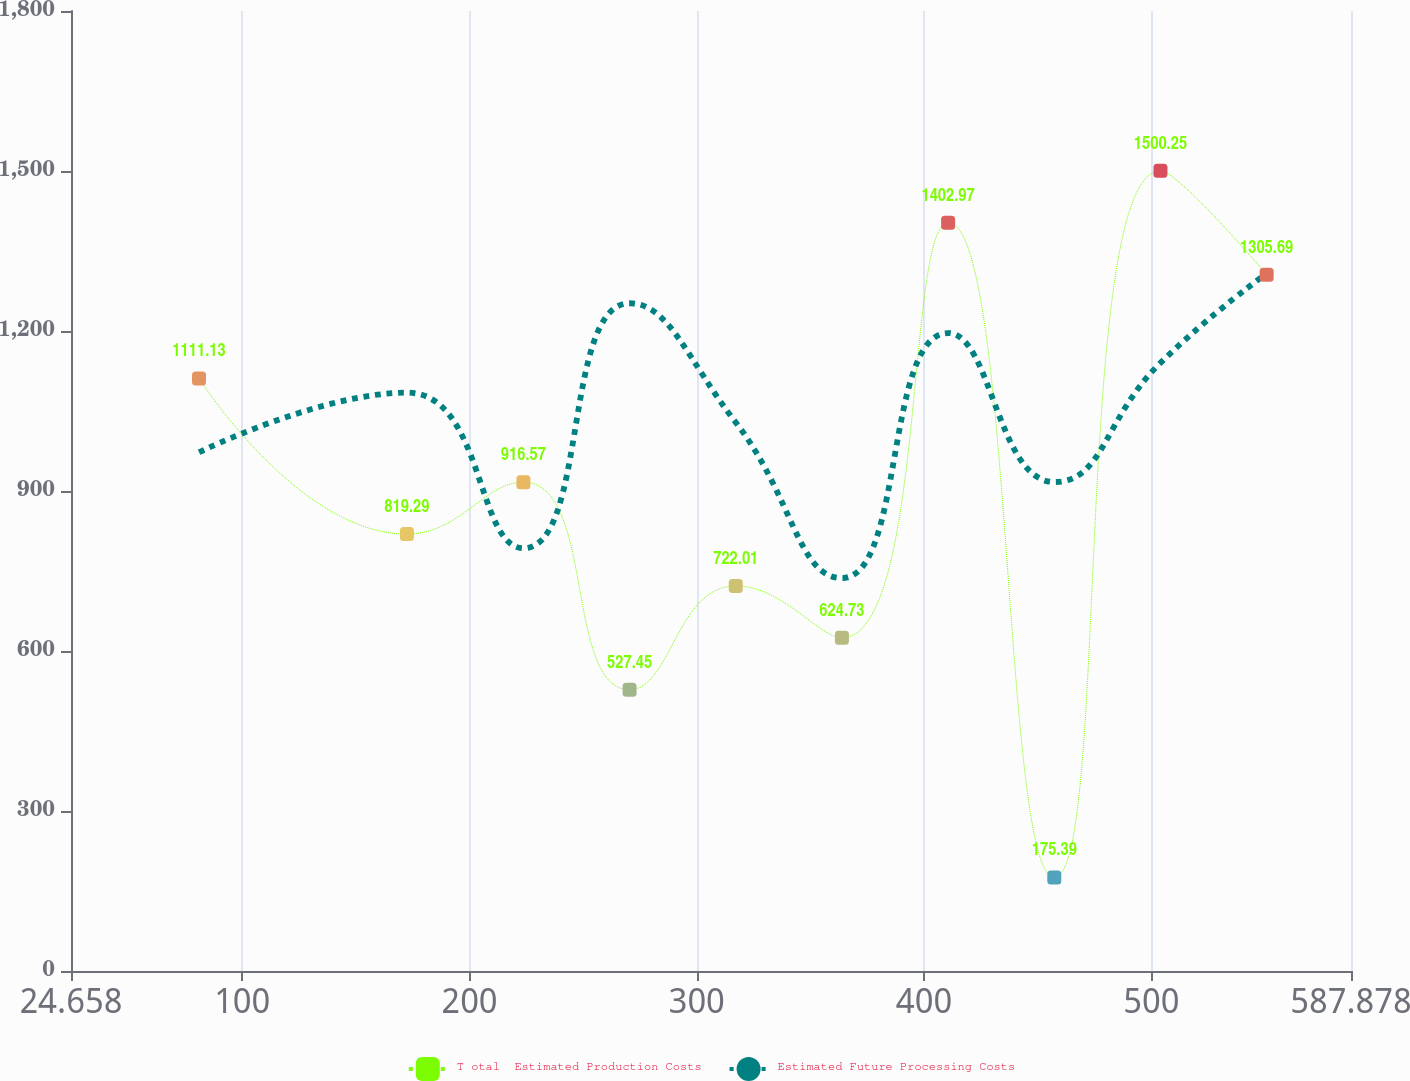Convert chart to OTSL. <chart><loc_0><loc_0><loc_500><loc_500><line_chart><ecel><fcel>T otal  Estimated Production Costs<fcel>Estimated Future Processing Costs<nl><fcel>80.98<fcel>1111.13<fcel>972.69<nl><fcel>172.47<fcel>819.29<fcel>1084.43<nl><fcel>223.72<fcel>916.57<fcel>792.68<nl><fcel>270.44<fcel>527.45<fcel>1252.04<nl><fcel>317.16<fcel>722.01<fcel>1028.56<nl><fcel>363.88<fcel>624.73<fcel>736.81<nl><fcel>410.6<fcel>1402.97<fcel>1196.17<nl><fcel>457.32<fcel>175.39<fcel>916.82<nl><fcel>504.04<fcel>1500.25<fcel>1140.3<nl><fcel>550.76<fcel>1305.69<fcel>1307.91<nl><fcel>597.48<fcel>1208.41<fcel>1419.65<nl><fcel>644.2<fcel>1013.85<fcel>1363.78<nl></chart> 